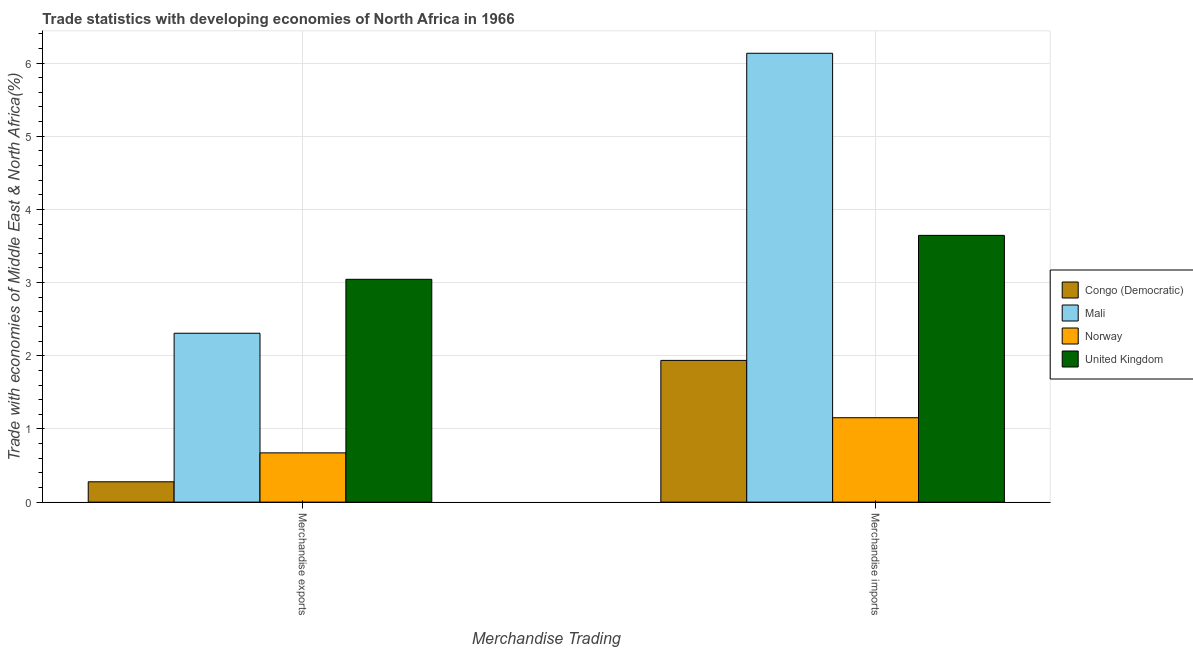How many groups of bars are there?
Your answer should be compact. 2. Are the number of bars per tick equal to the number of legend labels?
Your answer should be very brief. Yes. Are the number of bars on each tick of the X-axis equal?
Give a very brief answer. Yes. How many bars are there on the 2nd tick from the left?
Your answer should be very brief. 4. What is the label of the 2nd group of bars from the left?
Offer a terse response. Merchandise imports. What is the merchandise imports in Norway?
Keep it short and to the point. 1.15. Across all countries, what is the maximum merchandise exports?
Offer a very short reply. 3.04. Across all countries, what is the minimum merchandise exports?
Your response must be concise. 0.28. In which country was the merchandise exports maximum?
Ensure brevity in your answer.  United Kingdom. In which country was the merchandise imports minimum?
Keep it short and to the point. Norway. What is the total merchandise exports in the graph?
Your answer should be compact. 6.3. What is the difference between the merchandise exports in Norway and that in Congo (Democratic)?
Keep it short and to the point. 0.4. What is the difference between the merchandise exports in Norway and the merchandise imports in Congo (Democratic)?
Ensure brevity in your answer.  -1.26. What is the average merchandise exports per country?
Keep it short and to the point. 1.58. What is the difference between the merchandise imports and merchandise exports in United Kingdom?
Keep it short and to the point. 0.6. In how many countries, is the merchandise exports greater than 2.6 %?
Offer a very short reply. 1. What is the ratio of the merchandise exports in Mali to that in Congo (Democratic)?
Give a very brief answer. 8.31. Is the merchandise exports in United Kingdom less than that in Congo (Democratic)?
Ensure brevity in your answer.  No. What does the 2nd bar from the left in Merchandise exports represents?
Make the answer very short. Mali. What does the 4th bar from the right in Merchandise exports represents?
Make the answer very short. Congo (Democratic). How many bars are there?
Offer a terse response. 8. How many countries are there in the graph?
Give a very brief answer. 4. Where does the legend appear in the graph?
Offer a terse response. Center right. How are the legend labels stacked?
Keep it short and to the point. Vertical. What is the title of the graph?
Provide a short and direct response. Trade statistics with developing economies of North Africa in 1966. Does "Ecuador" appear as one of the legend labels in the graph?
Offer a terse response. No. What is the label or title of the X-axis?
Make the answer very short. Merchandise Trading. What is the label or title of the Y-axis?
Your answer should be compact. Trade with economies of Middle East & North Africa(%). What is the Trade with economies of Middle East & North Africa(%) in Congo (Democratic) in Merchandise exports?
Make the answer very short. 0.28. What is the Trade with economies of Middle East & North Africa(%) of Mali in Merchandise exports?
Your response must be concise. 2.31. What is the Trade with economies of Middle East & North Africa(%) in Norway in Merchandise exports?
Provide a succinct answer. 0.67. What is the Trade with economies of Middle East & North Africa(%) of United Kingdom in Merchandise exports?
Keep it short and to the point. 3.04. What is the Trade with economies of Middle East & North Africa(%) of Congo (Democratic) in Merchandise imports?
Offer a very short reply. 1.94. What is the Trade with economies of Middle East & North Africa(%) of Mali in Merchandise imports?
Make the answer very short. 6.13. What is the Trade with economies of Middle East & North Africa(%) in Norway in Merchandise imports?
Make the answer very short. 1.15. What is the Trade with economies of Middle East & North Africa(%) in United Kingdom in Merchandise imports?
Your response must be concise. 3.65. Across all Merchandise Trading, what is the maximum Trade with economies of Middle East & North Africa(%) in Congo (Democratic)?
Provide a short and direct response. 1.94. Across all Merchandise Trading, what is the maximum Trade with economies of Middle East & North Africa(%) in Mali?
Your response must be concise. 6.13. Across all Merchandise Trading, what is the maximum Trade with economies of Middle East & North Africa(%) of Norway?
Provide a short and direct response. 1.15. Across all Merchandise Trading, what is the maximum Trade with economies of Middle East & North Africa(%) in United Kingdom?
Your answer should be very brief. 3.65. Across all Merchandise Trading, what is the minimum Trade with economies of Middle East & North Africa(%) in Congo (Democratic)?
Provide a succinct answer. 0.28. Across all Merchandise Trading, what is the minimum Trade with economies of Middle East & North Africa(%) of Mali?
Provide a short and direct response. 2.31. Across all Merchandise Trading, what is the minimum Trade with economies of Middle East & North Africa(%) in Norway?
Offer a terse response. 0.67. Across all Merchandise Trading, what is the minimum Trade with economies of Middle East & North Africa(%) in United Kingdom?
Keep it short and to the point. 3.04. What is the total Trade with economies of Middle East & North Africa(%) of Congo (Democratic) in the graph?
Provide a short and direct response. 2.21. What is the total Trade with economies of Middle East & North Africa(%) of Mali in the graph?
Your answer should be very brief. 8.44. What is the total Trade with economies of Middle East & North Africa(%) in Norway in the graph?
Offer a very short reply. 1.83. What is the total Trade with economies of Middle East & North Africa(%) of United Kingdom in the graph?
Provide a succinct answer. 6.69. What is the difference between the Trade with economies of Middle East & North Africa(%) of Congo (Democratic) in Merchandise exports and that in Merchandise imports?
Offer a very short reply. -1.66. What is the difference between the Trade with economies of Middle East & North Africa(%) in Mali in Merchandise exports and that in Merchandise imports?
Your answer should be very brief. -3.83. What is the difference between the Trade with economies of Middle East & North Africa(%) of Norway in Merchandise exports and that in Merchandise imports?
Your response must be concise. -0.48. What is the difference between the Trade with economies of Middle East & North Africa(%) of United Kingdom in Merchandise exports and that in Merchandise imports?
Make the answer very short. -0.6. What is the difference between the Trade with economies of Middle East & North Africa(%) in Congo (Democratic) in Merchandise exports and the Trade with economies of Middle East & North Africa(%) in Mali in Merchandise imports?
Your answer should be very brief. -5.86. What is the difference between the Trade with economies of Middle East & North Africa(%) in Congo (Democratic) in Merchandise exports and the Trade with economies of Middle East & North Africa(%) in Norway in Merchandise imports?
Your answer should be very brief. -0.88. What is the difference between the Trade with economies of Middle East & North Africa(%) in Congo (Democratic) in Merchandise exports and the Trade with economies of Middle East & North Africa(%) in United Kingdom in Merchandise imports?
Your answer should be compact. -3.37. What is the difference between the Trade with economies of Middle East & North Africa(%) in Mali in Merchandise exports and the Trade with economies of Middle East & North Africa(%) in Norway in Merchandise imports?
Provide a succinct answer. 1.15. What is the difference between the Trade with economies of Middle East & North Africa(%) of Mali in Merchandise exports and the Trade with economies of Middle East & North Africa(%) of United Kingdom in Merchandise imports?
Keep it short and to the point. -1.34. What is the difference between the Trade with economies of Middle East & North Africa(%) in Norway in Merchandise exports and the Trade with economies of Middle East & North Africa(%) in United Kingdom in Merchandise imports?
Make the answer very short. -2.97. What is the average Trade with economies of Middle East & North Africa(%) of Congo (Democratic) per Merchandise Trading?
Keep it short and to the point. 1.11. What is the average Trade with economies of Middle East & North Africa(%) of Mali per Merchandise Trading?
Give a very brief answer. 4.22. What is the average Trade with economies of Middle East & North Africa(%) in Norway per Merchandise Trading?
Your answer should be compact. 0.91. What is the average Trade with economies of Middle East & North Africa(%) in United Kingdom per Merchandise Trading?
Make the answer very short. 3.34. What is the difference between the Trade with economies of Middle East & North Africa(%) in Congo (Democratic) and Trade with economies of Middle East & North Africa(%) in Mali in Merchandise exports?
Offer a terse response. -2.03. What is the difference between the Trade with economies of Middle East & North Africa(%) of Congo (Democratic) and Trade with economies of Middle East & North Africa(%) of Norway in Merchandise exports?
Provide a succinct answer. -0.4. What is the difference between the Trade with economies of Middle East & North Africa(%) in Congo (Democratic) and Trade with economies of Middle East & North Africa(%) in United Kingdom in Merchandise exports?
Keep it short and to the point. -2.77. What is the difference between the Trade with economies of Middle East & North Africa(%) of Mali and Trade with economies of Middle East & North Africa(%) of Norway in Merchandise exports?
Your answer should be very brief. 1.63. What is the difference between the Trade with economies of Middle East & North Africa(%) in Mali and Trade with economies of Middle East & North Africa(%) in United Kingdom in Merchandise exports?
Give a very brief answer. -0.74. What is the difference between the Trade with economies of Middle East & North Africa(%) in Norway and Trade with economies of Middle East & North Africa(%) in United Kingdom in Merchandise exports?
Keep it short and to the point. -2.37. What is the difference between the Trade with economies of Middle East & North Africa(%) of Congo (Democratic) and Trade with economies of Middle East & North Africa(%) of Mali in Merchandise imports?
Provide a succinct answer. -4.2. What is the difference between the Trade with economies of Middle East & North Africa(%) of Congo (Democratic) and Trade with economies of Middle East & North Africa(%) of Norway in Merchandise imports?
Offer a very short reply. 0.78. What is the difference between the Trade with economies of Middle East & North Africa(%) of Congo (Democratic) and Trade with economies of Middle East & North Africa(%) of United Kingdom in Merchandise imports?
Offer a terse response. -1.71. What is the difference between the Trade with economies of Middle East & North Africa(%) of Mali and Trade with economies of Middle East & North Africa(%) of Norway in Merchandise imports?
Provide a short and direct response. 4.98. What is the difference between the Trade with economies of Middle East & North Africa(%) of Mali and Trade with economies of Middle East & North Africa(%) of United Kingdom in Merchandise imports?
Provide a short and direct response. 2.49. What is the difference between the Trade with economies of Middle East & North Africa(%) in Norway and Trade with economies of Middle East & North Africa(%) in United Kingdom in Merchandise imports?
Your answer should be very brief. -2.49. What is the ratio of the Trade with economies of Middle East & North Africa(%) in Congo (Democratic) in Merchandise exports to that in Merchandise imports?
Offer a very short reply. 0.14. What is the ratio of the Trade with economies of Middle East & North Africa(%) of Mali in Merchandise exports to that in Merchandise imports?
Provide a succinct answer. 0.38. What is the ratio of the Trade with economies of Middle East & North Africa(%) in Norway in Merchandise exports to that in Merchandise imports?
Give a very brief answer. 0.58. What is the ratio of the Trade with economies of Middle East & North Africa(%) in United Kingdom in Merchandise exports to that in Merchandise imports?
Your answer should be very brief. 0.84. What is the difference between the highest and the second highest Trade with economies of Middle East & North Africa(%) of Congo (Democratic)?
Give a very brief answer. 1.66. What is the difference between the highest and the second highest Trade with economies of Middle East & North Africa(%) in Mali?
Give a very brief answer. 3.83. What is the difference between the highest and the second highest Trade with economies of Middle East & North Africa(%) in Norway?
Offer a terse response. 0.48. What is the difference between the highest and the second highest Trade with economies of Middle East & North Africa(%) in United Kingdom?
Your response must be concise. 0.6. What is the difference between the highest and the lowest Trade with economies of Middle East & North Africa(%) of Congo (Democratic)?
Ensure brevity in your answer.  1.66. What is the difference between the highest and the lowest Trade with economies of Middle East & North Africa(%) in Mali?
Provide a succinct answer. 3.83. What is the difference between the highest and the lowest Trade with economies of Middle East & North Africa(%) of Norway?
Offer a terse response. 0.48. What is the difference between the highest and the lowest Trade with economies of Middle East & North Africa(%) in United Kingdom?
Your response must be concise. 0.6. 